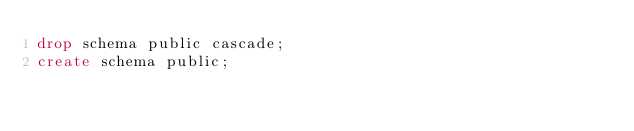<code> <loc_0><loc_0><loc_500><loc_500><_SQL_>drop schema public cascade;
create schema public;</code> 